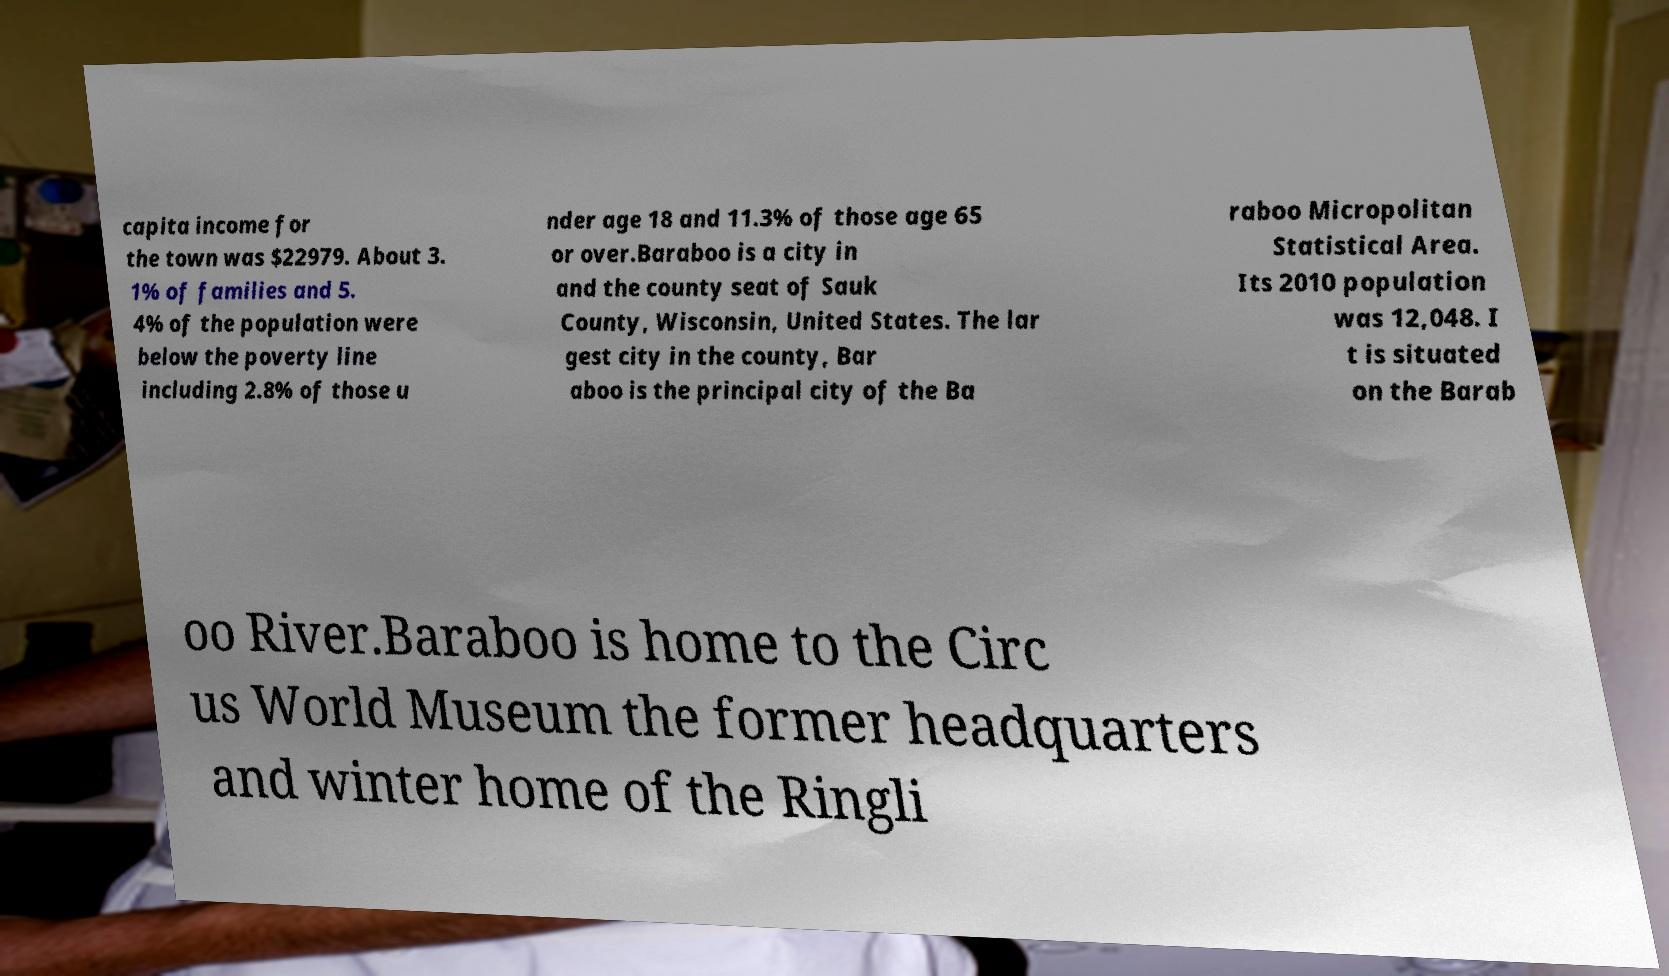I need the written content from this picture converted into text. Can you do that? capita income for the town was $22979. About 3. 1% of families and 5. 4% of the population were below the poverty line including 2.8% of those u nder age 18 and 11.3% of those age 65 or over.Baraboo is a city in and the county seat of Sauk County, Wisconsin, United States. The lar gest city in the county, Bar aboo is the principal city of the Ba raboo Micropolitan Statistical Area. Its 2010 population was 12,048. I t is situated on the Barab oo River.Baraboo is home to the Circ us World Museum the former headquarters and winter home of the Ringli 